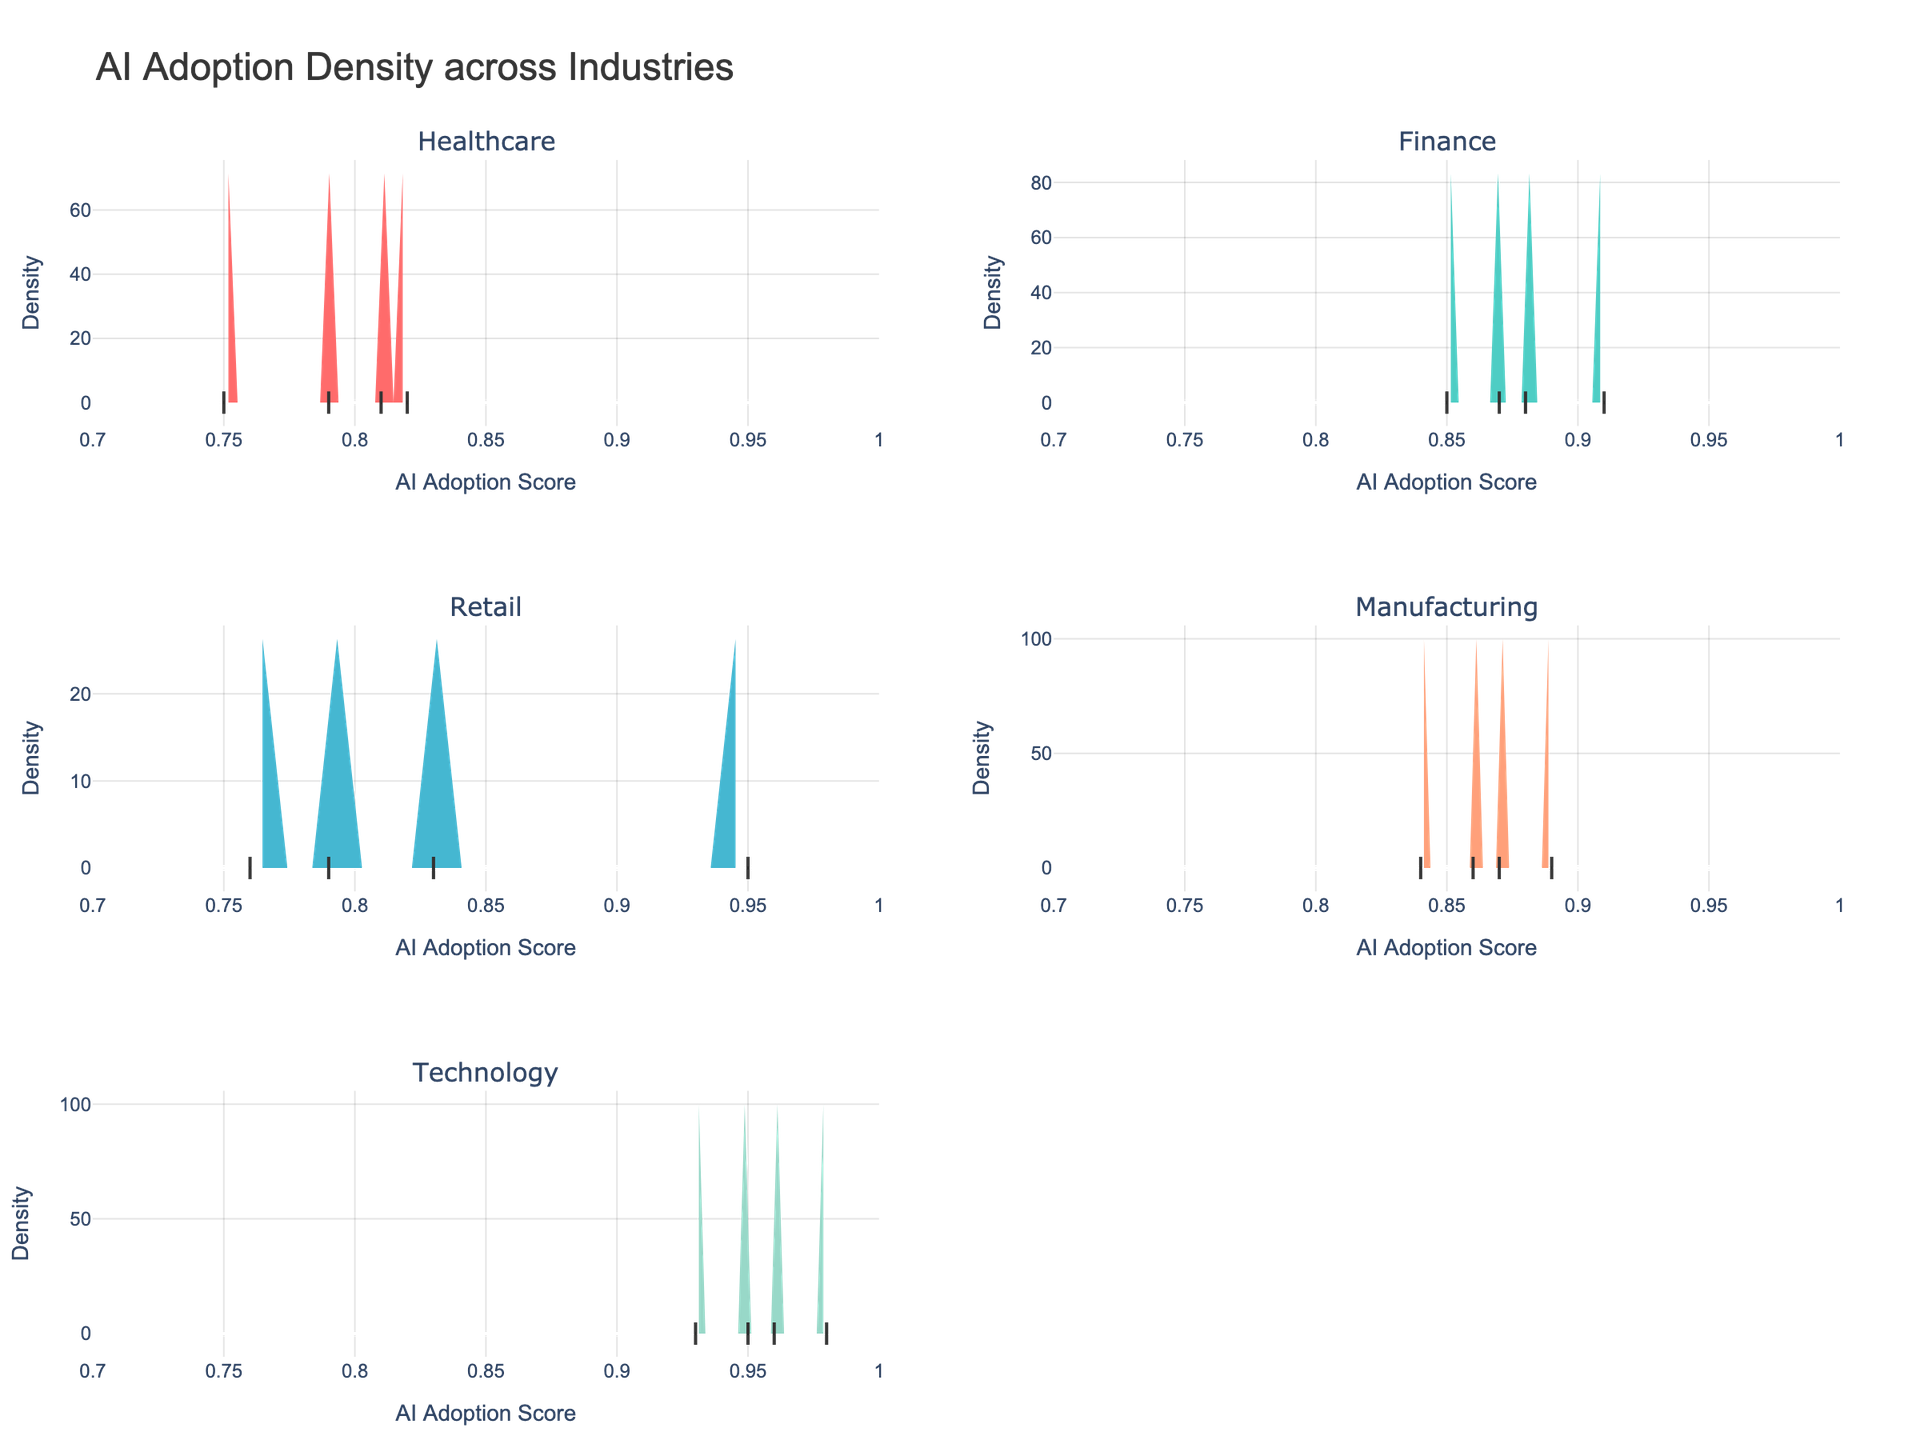What is the title of the figure? The title of the figure is displayed at the top of the plot and clearly states what the figure is about. In this case, it is "AI Adoption Density across Industries".
Answer: AI Adoption Density across Industries Which industry shows the highest peak in the density plot? By observing the height of the peaks in the density plots for each industry, the Technology industry clearly shows the highest peak.
Answer: Technology How many industries are represented in the figure? By looking at the subplot titles, we can count the number of unique industries shown in the figure. There are six subplot titles present.
Answer: Six Between Finance and Healthcare, which industry has a wider spread in AI Adoption Scores? The spread can be judged by the width of the density plots. Observing the width, Finance shows a slightly wider spread compared to Healthcare.
Answer: Finance What is the range of AI Adoption Scores on the x-axis? By checking the range specified on the x-axis across all subplots, the minimum score is 0.7 and the maximum score is 1.0.
Answer: 0.7 to 1.0 Which industry has the most concentrated AI Adoption Scores? By looking for the narrowest peak with the highest density, the Technology industry is the most concentrated around its peak, indicating concentrated scores.
Answer: Technology What is the approximate AI Adoption Score for the peak density in Retail? Observing the peak of the density plot for Retail, the highest point occurs around an AI Adoption Score of 0.80 to 0.82.
Answer: Around 0.80 to 0.82 Comparing Manufacturing and Retail, which industry has a higher median AI Adoption Score? To find the median, look for the central peak in their respective density plots. Manufacturing shows a central peak around 0.86, while Retail's central peak is around 0.80. Thus, Manufacturing has a higher median.
Answer: Manufacturing What trend can be observed in the distribution of AI Adoption Scores for the Finance industry? By examining the density plot for Finance, it shows a relatively consistent spread with a peak indicating a slight concentration around 0.86 to 0.88.
Answer: Consistent spread with a peak around 0.86 to 0.88 How are the data points visually represented in the subplots? The small points at the base of each density curve represent the individual data points from each industry.
Answer: Small points at the base of each density curve 